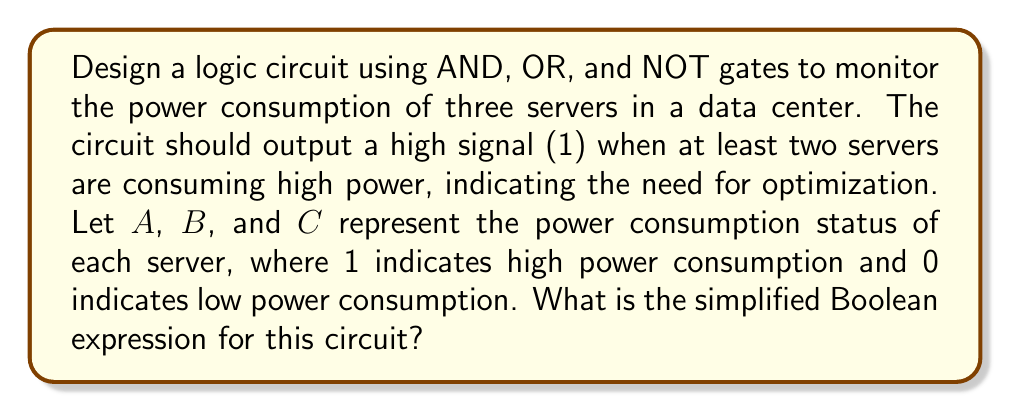Could you help me with this problem? Let's approach this step-by-step:

1) First, we need to identify the conditions when the output should be 1. This occurs when at least two servers are consuming high power. The possible combinations are:
   - A = 1, B = 1, C = 0
   - A = 1, B = 0, C = 1
   - A = 0, B = 1, C = 1
   - A = 1, B = 1, C = 1

2) We can express this as a Boolean function:
   $$F = AB\overline{C} + A\overline{B}C + \overline{A}BC + ABC$$

3) This can be simplified using Boolean algebra:
   $$F = AB\overline{C} + A\overline{B}C + \overline{A}BC + ABC$$
   $$= AB(\overline{C} + C) + AC(\overline{B} + B) + BC(\overline{A} + A)$$
   $$= AB + AC + BC$$

4) This simplified expression, $AB + AC + BC$, represents the logical OR of all possible combinations where two variables are 1.

5) To implement this with basic logic gates:
   - We need three AND gates to compute AB, AC, and BC
   - We need two OR gates to combine these terms

6) The resulting circuit will output 1 when at least two servers are consuming high power, prompting the need for power optimization.
Answer: $AB + AC + BC$ 